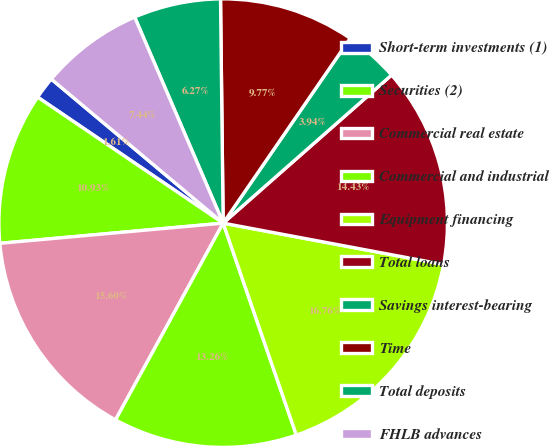<chart> <loc_0><loc_0><loc_500><loc_500><pie_chart><fcel>Short-term investments (1)<fcel>Securities (2)<fcel>Commercial real estate<fcel>Commercial and industrial<fcel>Equipment financing<fcel>Total loans<fcel>Savings interest-bearing<fcel>Time<fcel>Total deposits<fcel>FHLB advances<nl><fcel>1.61%<fcel>10.93%<fcel>15.6%<fcel>13.26%<fcel>16.76%<fcel>14.43%<fcel>3.94%<fcel>9.77%<fcel>6.27%<fcel>7.44%<nl></chart> 